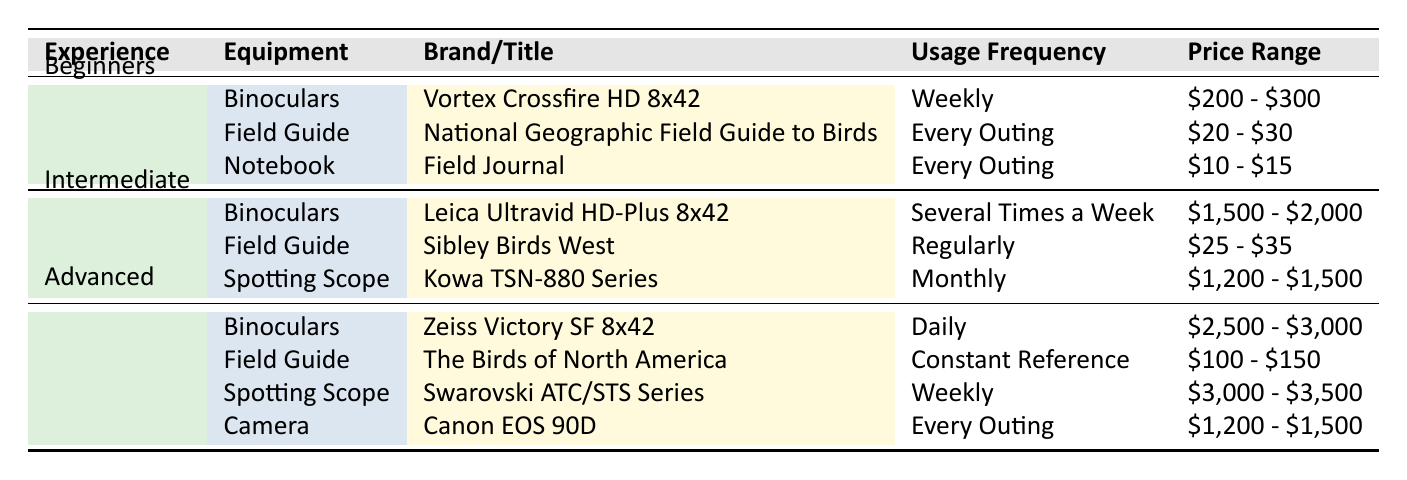What binoculars do beginners use for birdwatching? According to the table, beginners use the Vortex Crossfire HD 8x42 binoculars.
Answer: Vortex Crossfire HD 8x42 How often do advanced birdwatchers use their spotting scope? The table shows that advanced birdwatchers use their spotting scope weekly.
Answer: Weekly What is the price range of the binoculars used by intermediate birdwatchers? For intermediate birdwatchers, the Leica Ultravid HD-Plus 8x42 binoculars have a price range of $1,500 - $2,000.
Answer: $1,500 - $2,000 Are beginners more likely to use a field guide every outing compared to advanced birdwatchers? Yes, beginners use a field guide every outing, while advanced birdwatchers use theirs as a constant reference; therefore, beginners are more likely to use it every outing.
Answer: Yes What is the difference in price range between the binoculars used by beginners and those used by advanced birdwatchers? The price range for beginners' binoculars is $200 - $300, while advanced birdwatchers use binoculars priced at $2,500 - $3,000. The difference between the lower end is $2,300 ($2,500 - $200) and higher end is $2,700 ($3,000 - $300), therefore the total difference is from $2,300 to $2,700.
Answer: $2,300 to $2,700 What camera do advanced birdwatchers use on every outing? The advanced birdwatchers use the Canon EOS 90D camera on every outing as indicated in the table.
Answer: Canon EOS 90D How frequently do intermediate birdwatchers refer to their field guide? Intermediate birdwatchers refer to their field guide regularly, according to the data.
Answer: Regularly Is the price range of the field guide used by beginners lower or higher than that used by advanced birdwatchers? The price range for the field guide used by beginners is $20 - $30, while the advanced birdwatchers have a field guide priced at $100 - $150. Since $20 is lower than $100, the price range for beginners is lower.
Answer: Lower 